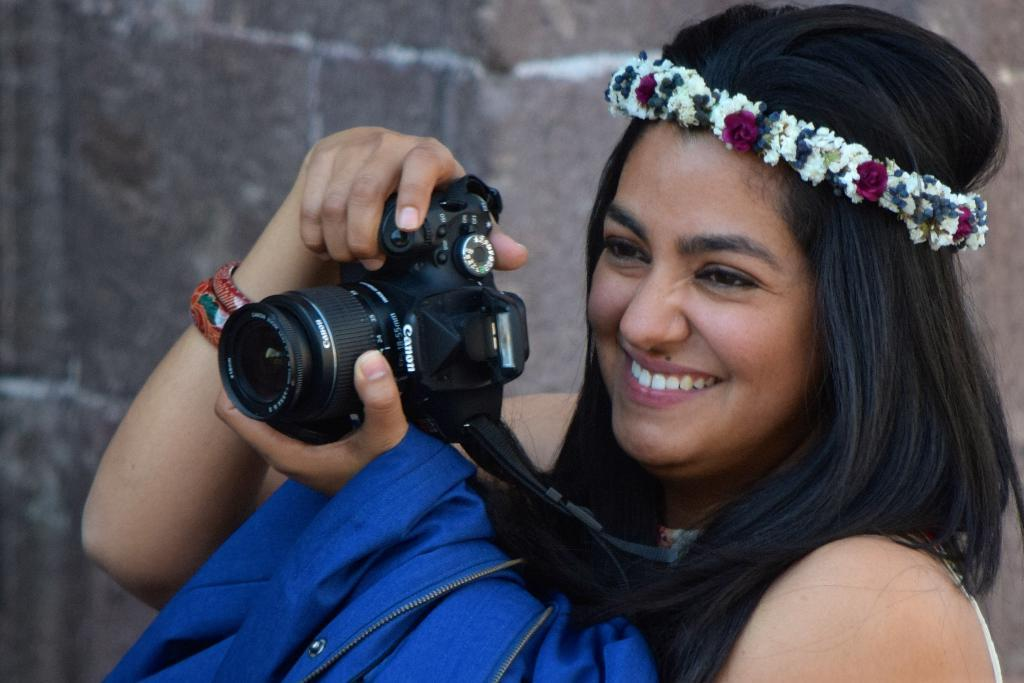What is the woman holding in the image? The woman is holding a camera. What expression does the woman have? The woman is smiling. What accessory is the woman wearing? The woman is wearing a crown. What else is the woman holding besides the camera? The woman is holding a jacket. How many clocks can be seen in the image? There are no clocks visible in the image. What type of trick is the woman performing in the image? There is no trick being performed in the image; the woman is simply holding a camera, wearing a crown, and smiling. 